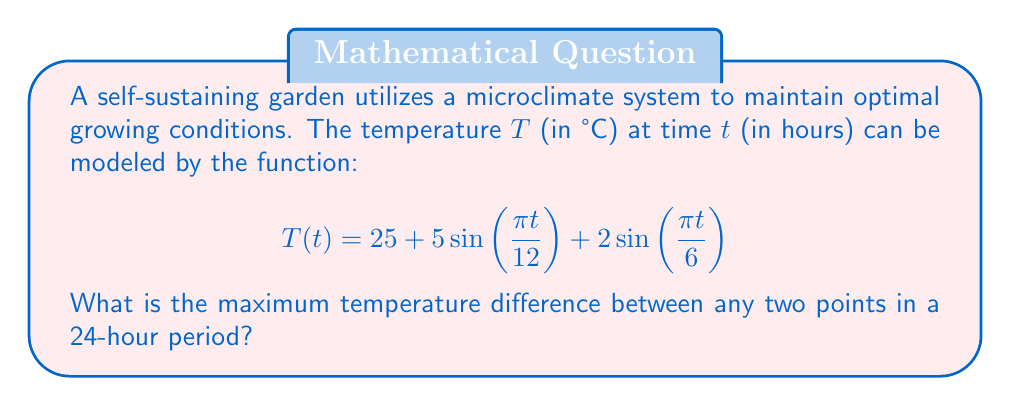What is the answer to this math problem? To find the maximum temperature difference, we need to determine the highest and lowest temperatures over a 24-hour period.

1. The function $T(t)$ has a period of 24 hours due to the $\sin(\frac{\pi t}{12})$ term.

2. To find extrema, we need to find where the derivative $T'(t)$ equals zero:

   $$T'(t) = \frac{5\pi}{12}\cos(\frac{\pi t}{12}) + \frac{\pi}{3}\cos(\frac{\pi t}{6})$$

3. Solving $T'(t) = 0$ analytically is complex, so we'll use a numerical approach.

4. By plotting or evaluating $T(t)$ at regular intervals, we can determine:
   - Maximum temperature occurs at approximately $t = 3$ or $t = 15$
   - Minimum temperature occurs at approximately $t = 9$ or $t = 21$

5. Calculate the temperatures:
   $$T(3) = 25 + 5\sin(\frac{\pi \cdot 3}{12}) + 2\sin(\frac{\pi \cdot 3}{6}) \approx 31.5°C$$
   $$T(9) = 25 + 5\sin(\frac{\pi \cdot 9}{12}) + 2\sin(\frac{\pi \cdot 9}{6}) \approx 18.5°C$$

6. The maximum temperature difference is:
   $$31.5°C - 18.5°C = 13°C$$

Therefore, the maximum temperature difference between any two points in a 24-hour period is approximately 13°C.
Answer: 13°C 